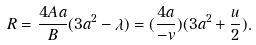Convert formula to latex. <formula><loc_0><loc_0><loc_500><loc_500>R = \frac { 4 A a } { B } ( 3 a ^ { 2 } - \lambda ) = ( \frac { 4 a } { - v } ) ( 3 a ^ { 2 } + \frac { u } { 2 } ) .</formula> 